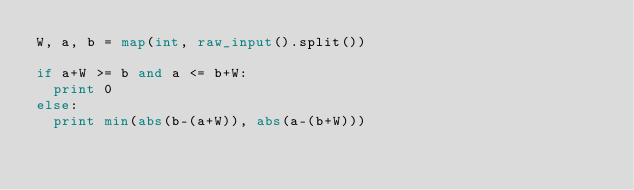<code> <loc_0><loc_0><loc_500><loc_500><_Python_>W, a, b = map(int, raw_input().split())

if a+W >= b and a <= b+W:
	print 0
else:
	print min(abs(b-(a+W)), abs(a-(b+W))) </code> 